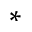Convert formula to latex. <formula><loc_0><loc_0><loc_500><loc_500>^ { \ast }</formula> 